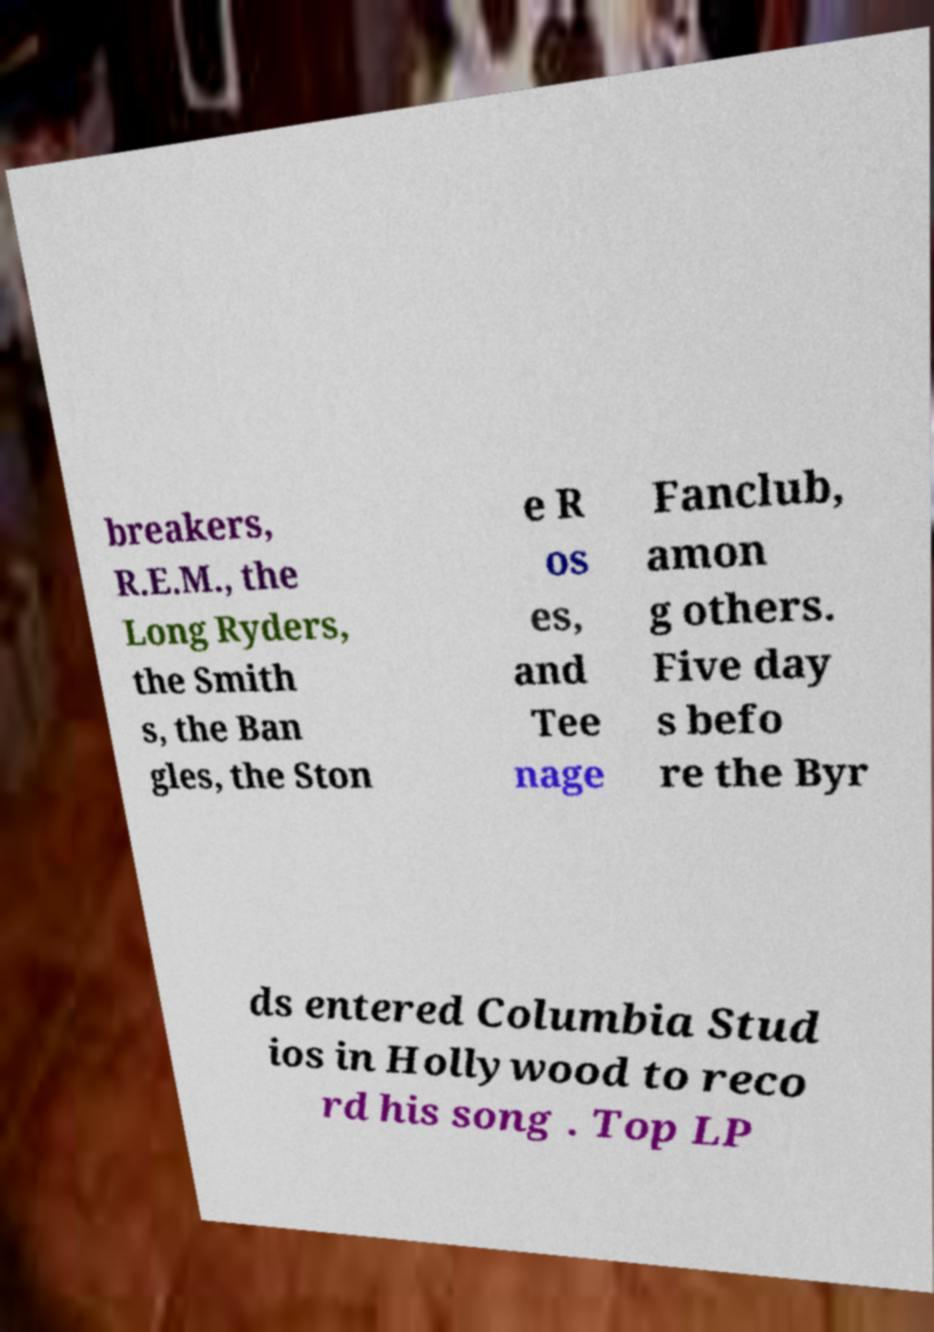For documentation purposes, I need the text within this image transcribed. Could you provide that? breakers, R.E.M., the Long Ryders, the Smith s, the Ban gles, the Ston e R os es, and Tee nage Fanclub, amon g others. Five day s befo re the Byr ds entered Columbia Stud ios in Hollywood to reco rd his song . Top LP 